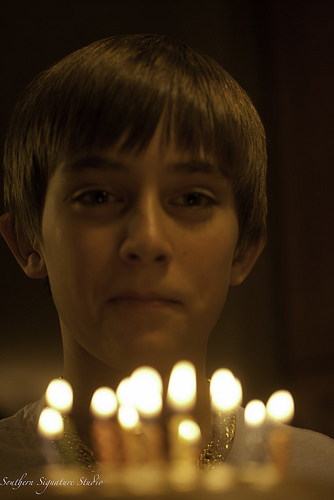<image>
Is the boy behind the necklace? No. The boy is not behind the necklace. From this viewpoint, the boy appears to be positioned elsewhere in the scene. 